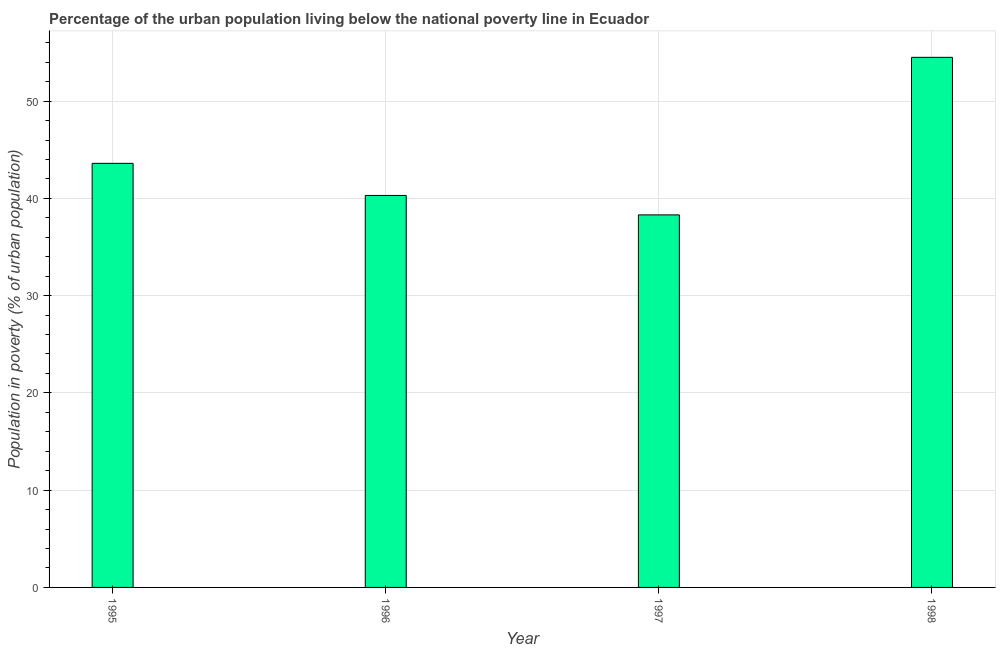Does the graph contain any zero values?
Give a very brief answer. No. Does the graph contain grids?
Make the answer very short. Yes. What is the title of the graph?
Keep it short and to the point. Percentage of the urban population living below the national poverty line in Ecuador. What is the label or title of the Y-axis?
Make the answer very short. Population in poverty (% of urban population). What is the percentage of urban population living below poverty line in 1996?
Provide a succinct answer. 40.3. Across all years, what is the maximum percentage of urban population living below poverty line?
Your answer should be very brief. 54.5. Across all years, what is the minimum percentage of urban population living below poverty line?
Offer a terse response. 38.3. What is the sum of the percentage of urban population living below poverty line?
Keep it short and to the point. 176.7. What is the average percentage of urban population living below poverty line per year?
Keep it short and to the point. 44.17. What is the median percentage of urban population living below poverty line?
Provide a succinct answer. 41.95. Do a majority of the years between 1995 and 1997 (inclusive) have percentage of urban population living below poverty line greater than 26 %?
Your answer should be very brief. Yes. What is the ratio of the percentage of urban population living below poverty line in 1996 to that in 1997?
Keep it short and to the point. 1.05. Is the percentage of urban population living below poverty line in 1996 less than that in 1998?
Your response must be concise. Yes. What is the difference between the highest and the second highest percentage of urban population living below poverty line?
Keep it short and to the point. 10.9. Is the sum of the percentage of urban population living below poverty line in 1995 and 1997 greater than the maximum percentage of urban population living below poverty line across all years?
Your answer should be very brief. Yes. What is the difference between the highest and the lowest percentage of urban population living below poverty line?
Make the answer very short. 16.2. In how many years, is the percentage of urban population living below poverty line greater than the average percentage of urban population living below poverty line taken over all years?
Offer a very short reply. 1. How many bars are there?
Offer a terse response. 4. How many years are there in the graph?
Your response must be concise. 4. What is the difference between two consecutive major ticks on the Y-axis?
Your answer should be compact. 10. Are the values on the major ticks of Y-axis written in scientific E-notation?
Your answer should be compact. No. What is the Population in poverty (% of urban population) of 1995?
Your answer should be very brief. 43.6. What is the Population in poverty (% of urban population) in 1996?
Provide a succinct answer. 40.3. What is the Population in poverty (% of urban population) in 1997?
Your response must be concise. 38.3. What is the Population in poverty (% of urban population) in 1998?
Keep it short and to the point. 54.5. What is the difference between the Population in poverty (% of urban population) in 1995 and 1998?
Offer a very short reply. -10.9. What is the difference between the Population in poverty (% of urban population) in 1996 and 1998?
Make the answer very short. -14.2. What is the difference between the Population in poverty (% of urban population) in 1997 and 1998?
Your response must be concise. -16.2. What is the ratio of the Population in poverty (% of urban population) in 1995 to that in 1996?
Your answer should be very brief. 1.08. What is the ratio of the Population in poverty (% of urban population) in 1995 to that in 1997?
Offer a very short reply. 1.14. What is the ratio of the Population in poverty (% of urban population) in 1996 to that in 1997?
Your response must be concise. 1.05. What is the ratio of the Population in poverty (% of urban population) in 1996 to that in 1998?
Provide a succinct answer. 0.74. What is the ratio of the Population in poverty (% of urban population) in 1997 to that in 1998?
Provide a succinct answer. 0.7. 